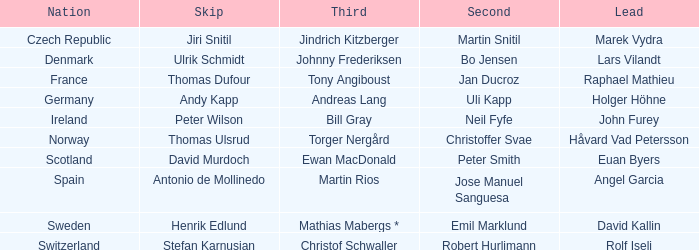Which skip contains a fraction that is one-third of tony angiboust? Thomas Dufour. Would you mind parsing the complete table? {'header': ['Nation', 'Skip', 'Third', 'Second', 'Lead'], 'rows': [['Czech Republic', 'Jiri Snitil', 'Jindrich Kitzberger', 'Martin Snitil', 'Marek Vydra'], ['Denmark', 'Ulrik Schmidt', 'Johnny Frederiksen', 'Bo Jensen', 'Lars Vilandt'], ['France', 'Thomas Dufour', 'Tony Angiboust', 'Jan Ducroz', 'Raphael Mathieu'], ['Germany', 'Andy Kapp', 'Andreas Lang', 'Uli Kapp', 'Holger Höhne'], ['Ireland', 'Peter Wilson', 'Bill Gray', 'Neil Fyfe', 'John Furey'], ['Norway', 'Thomas Ulsrud', 'Torger Nergård', 'Christoffer Svae', 'Håvard Vad Petersson'], ['Scotland', 'David Murdoch', 'Ewan MacDonald', 'Peter Smith', 'Euan Byers'], ['Spain', 'Antonio de Mollinedo', 'Martin Rios', 'Jose Manuel Sanguesa', 'Angel Garcia'], ['Sweden', 'Henrik Edlund', 'Mathias Mabergs *', 'Emil Marklund', 'David Kallin'], ['Switzerland', 'Stefan Karnusian', 'Christof Schwaller', 'Robert Hurlimann', 'Rolf Iseli']]} 